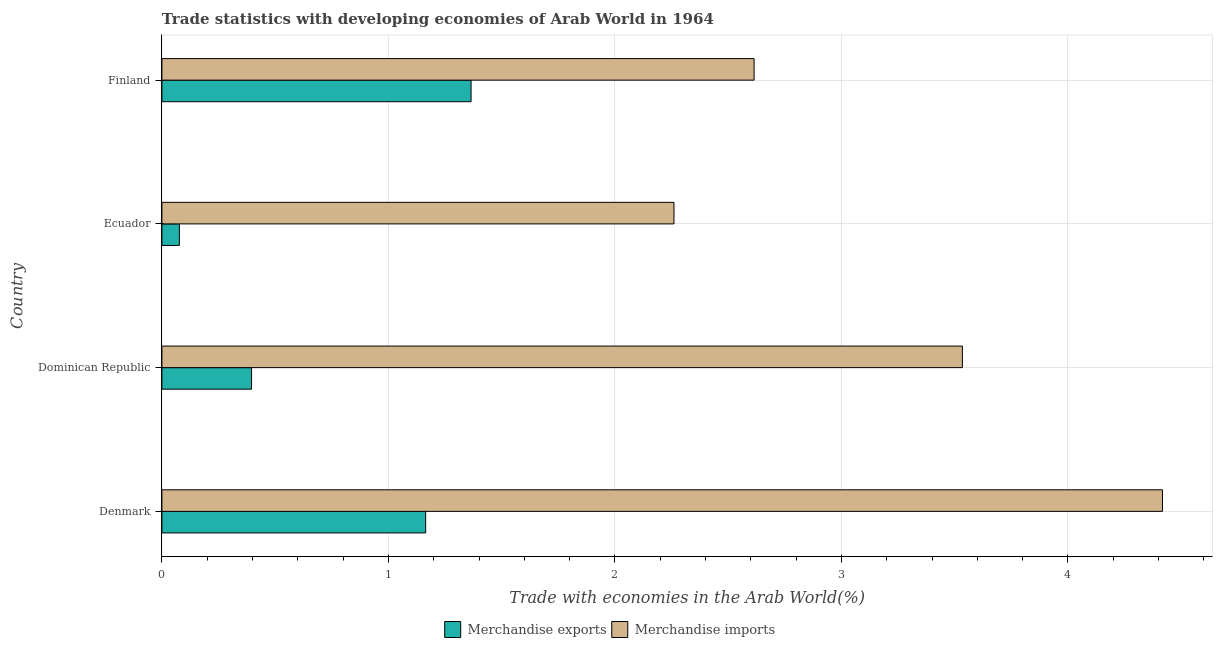How many groups of bars are there?
Offer a terse response. 4. Are the number of bars on each tick of the Y-axis equal?
Make the answer very short. Yes. How many bars are there on the 3rd tick from the top?
Offer a terse response. 2. How many bars are there on the 4th tick from the bottom?
Offer a very short reply. 2. What is the merchandise imports in Dominican Republic?
Your response must be concise. 3.53. Across all countries, what is the maximum merchandise imports?
Ensure brevity in your answer.  4.42. Across all countries, what is the minimum merchandise exports?
Provide a short and direct response. 0.08. In which country was the merchandise exports minimum?
Your answer should be very brief. Ecuador. What is the total merchandise exports in the graph?
Your answer should be very brief. 3. What is the difference between the merchandise exports in Dominican Republic and that in Ecuador?
Make the answer very short. 0.32. What is the difference between the merchandise imports in Dominican Republic and the merchandise exports in Finland?
Give a very brief answer. 2.17. What is the average merchandise imports per country?
Your answer should be compact. 3.21. What is the difference between the merchandise imports and merchandise exports in Finland?
Give a very brief answer. 1.25. What is the ratio of the merchandise imports in Dominican Republic to that in Ecuador?
Offer a terse response. 1.56. Is the merchandise imports in Dominican Republic less than that in Finland?
Your answer should be very brief. No. What is the difference between the highest and the second highest merchandise exports?
Offer a very short reply. 0.2. What is the difference between the highest and the lowest merchandise imports?
Your answer should be compact. 2.16. What does the 1st bar from the top in Dominican Republic represents?
Keep it short and to the point. Merchandise imports. What does the 2nd bar from the bottom in Dominican Republic represents?
Ensure brevity in your answer.  Merchandise imports. Are all the bars in the graph horizontal?
Your answer should be compact. Yes. How many countries are there in the graph?
Provide a short and direct response. 4. What is the difference between two consecutive major ticks on the X-axis?
Make the answer very short. 1. Where does the legend appear in the graph?
Provide a short and direct response. Bottom center. How many legend labels are there?
Offer a very short reply. 2. What is the title of the graph?
Ensure brevity in your answer.  Trade statistics with developing economies of Arab World in 1964. Does "Public funds" appear as one of the legend labels in the graph?
Provide a short and direct response. No. What is the label or title of the X-axis?
Your answer should be very brief. Trade with economies in the Arab World(%). What is the label or title of the Y-axis?
Your answer should be compact. Country. What is the Trade with economies in the Arab World(%) of Merchandise exports in Denmark?
Give a very brief answer. 1.16. What is the Trade with economies in the Arab World(%) of Merchandise imports in Denmark?
Ensure brevity in your answer.  4.42. What is the Trade with economies in the Arab World(%) in Merchandise exports in Dominican Republic?
Provide a succinct answer. 0.4. What is the Trade with economies in the Arab World(%) of Merchandise imports in Dominican Republic?
Offer a very short reply. 3.53. What is the Trade with economies in the Arab World(%) in Merchandise exports in Ecuador?
Provide a short and direct response. 0.08. What is the Trade with economies in the Arab World(%) in Merchandise imports in Ecuador?
Offer a terse response. 2.26. What is the Trade with economies in the Arab World(%) of Merchandise exports in Finland?
Your answer should be compact. 1.36. What is the Trade with economies in the Arab World(%) in Merchandise imports in Finland?
Provide a succinct answer. 2.61. Across all countries, what is the maximum Trade with economies in the Arab World(%) of Merchandise exports?
Your response must be concise. 1.36. Across all countries, what is the maximum Trade with economies in the Arab World(%) in Merchandise imports?
Ensure brevity in your answer.  4.42. Across all countries, what is the minimum Trade with economies in the Arab World(%) of Merchandise exports?
Provide a succinct answer. 0.08. Across all countries, what is the minimum Trade with economies in the Arab World(%) in Merchandise imports?
Offer a terse response. 2.26. What is the total Trade with economies in the Arab World(%) of Merchandise exports in the graph?
Provide a short and direct response. 3. What is the total Trade with economies in the Arab World(%) of Merchandise imports in the graph?
Make the answer very short. 12.83. What is the difference between the Trade with economies in the Arab World(%) in Merchandise exports in Denmark and that in Dominican Republic?
Your response must be concise. 0.77. What is the difference between the Trade with economies in the Arab World(%) in Merchandise imports in Denmark and that in Dominican Republic?
Make the answer very short. 0.88. What is the difference between the Trade with economies in the Arab World(%) in Merchandise exports in Denmark and that in Ecuador?
Offer a terse response. 1.09. What is the difference between the Trade with economies in the Arab World(%) in Merchandise imports in Denmark and that in Ecuador?
Your answer should be very brief. 2.16. What is the difference between the Trade with economies in the Arab World(%) of Merchandise exports in Denmark and that in Finland?
Offer a very short reply. -0.2. What is the difference between the Trade with economies in the Arab World(%) of Merchandise imports in Denmark and that in Finland?
Your answer should be compact. 1.8. What is the difference between the Trade with economies in the Arab World(%) in Merchandise exports in Dominican Republic and that in Ecuador?
Provide a succinct answer. 0.32. What is the difference between the Trade with economies in the Arab World(%) in Merchandise imports in Dominican Republic and that in Ecuador?
Ensure brevity in your answer.  1.27. What is the difference between the Trade with economies in the Arab World(%) of Merchandise exports in Dominican Republic and that in Finland?
Keep it short and to the point. -0.97. What is the difference between the Trade with economies in the Arab World(%) of Merchandise imports in Dominican Republic and that in Finland?
Keep it short and to the point. 0.92. What is the difference between the Trade with economies in the Arab World(%) in Merchandise exports in Ecuador and that in Finland?
Offer a terse response. -1.29. What is the difference between the Trade with economies in the Arab World(%) in Merchandise imports in Ecuador and that in Finland?
Provide a succinct answer. -0.35. What is the difference between the Trade with economies in the Arab World(%) of Merchandise exports in Denmark and the Trade with economies in the Arab World(%) of Merchandise imports in Dominican Republic?
Your answer should be compact. -2.37. What is the difference between the Trade with economies in the Arab World(%) of Merchandise exports in Denmark and the Trade with economies in the Arab World(%) of Merchandise imports in Ecuador?
Provide a succinct answer. -1.1. What is the difference between the Trade with economies in the Arab World(%) of Merchandise exports in Denmark and the Trade with economies in the Arab World(%) of Merchandise imports in Finland?
Keep it short and to the point. -1.45. What is the difference between the Trade with economies in the Arab World(%) of Merchandise exports in Dominican Republic and the Trade with economies in the Arab World(%) of Merchandise imports in Ecuador?
Your answer should be compact. -1.86. What is the difference between the Trade with economies in the Arab World(%) in Merchandise exports in Dominican Republic and the Trade with economies in the Arab World(%) in Merchandise imports in Finland?
Your response must be concise. -2.22. What is the difference between the Trade with economies in the Arab World(%) in Merchandise exports in Ecuador and the Trade with economies in the Arab World(%) in Merchandise imports in Finland?
Offer a terse response. -2.54. What is the average Trade with economies in the Arab World(%) of Merchandise exports per country?
Provide a short and direct response. 0.75. What is the average Trade with economies in the Arab World(%) in Merchandise imports per country?
Keep it short and to the point. 3.21. What is the difference between the Trade with economies in the Arab World(%) in Merchandise exports and Trade with economies in the Arab World(%) in Merchandise imports in Denmark?
Make the answer very short. -3.25. What is the difference between the Trade with economies in the Arab World(%) in Merchandise exports and Trade with economies in the Arab World(%) in Merchandise imports in Dominican Republic?
Your answer should be compact. -3.14. What is the difference between the Trade with economies in the Arab World(%) in Merchandise exports and Trade with economies in the Arab World(%) in Merchandise imports in Ecuador?
Provide a succinct answer. -2.18. What is the difference between the Trade with economies in the Arab World(%) in Merchandise exports and Trade with economies in the Arab World(%) in Merchandise imports in Finland?
Offer a terse response. -1.25. What is the ratio of the Trade with economies in the Arab World(%) in Merchandise exports in Denmark to that in Dominican Republic?
Provide a short and direct response. 2.94. What is the ratio of the Trade with economies in the Arab World(%) in Merchandise imports in Denmark to that in Dominican Republic?
Offer a very short reply. 1.25. What is the ratio of the Trade with economies in the Arab World(%) of Merchandise exports in Denmark to that in Ecuador?
Provide a short and direct response. 15.1. What is the ratio of the Trade with economies in the Arab World(%) in Merchandise imports in Denmark to that in Ecuador?
Provide a short and direct response. 1.95. What is the ratio of the Trade with economies in the Arab World(%) of Merchandise exports in Denmark to that in Finland?
Your answer should be compact. 0.85. What is the ratio of the Trade with economies in the Arab World(%) in Merchandise imports in Denmark to that in Finland?
Offer a very short reply. 1.69. What is the ratio of the Trade with economies in the Arab World(%) of Merchandise exports in Dominican Republic to that in Ecuador?
Your answer should be compact. 5.13. What is the ratio of the Trade with economies in the Arab World(%) of Merchandise imports in Dominican Republic to that in Ecuador?
Ensure brevity in your answer.  1.56. What is the ratio of the Trade with economies in the Arab World(%) of Merchandise exports in Dominican Republic to that in Finland?
Keep it short and to the point. 0.29. What is the ratio of the Trade with economies in the Arab World(%) of Merchandise imports in Dominican Republic to that in Finland?
Provide a succinct answer. 1.35. What is the ratio of the Trade with economies in the Arab World(%) in Merchandise exports in Ecuador to that in Finland?
Keep it short and to the point. 0.06. What is the ratio of the Trade with economies in the Arab World(%) of Merchandise imports in Ecuador to that in Finland?
Give a very brief answer. 0.86. What is the difference between the highest and the second highest Trade with economies in the Arab World(%) of Merchandise exports?
Offer a terse response. 0.2. What is the difference between the highest and the second highest Trade with economies in the Arab World(%) of Merchandise imports?
Your answer should be compact. 0.88. What is the difference between the highest and the lowest Trade with economies in the Arab World(%) of Merchandise exports?
Offer a terse response. 1.29. What is the difference between the highest and the lowest Trade with economies in the Arab World(%) of Merchandise imports?
Keep it short and to the point. 2.16. 